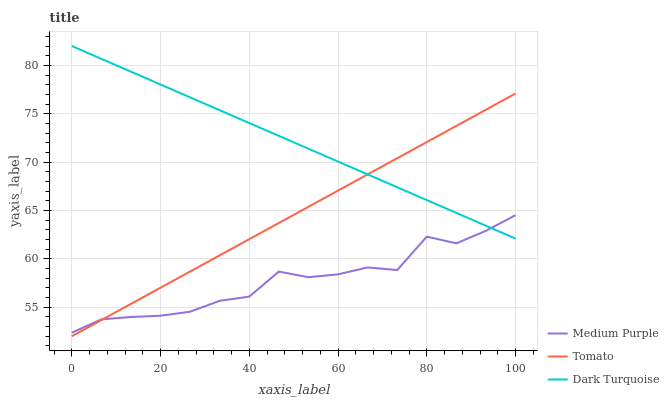Does Medium Purple have the minimum area under the curve?
Answer yes or no. Yes. Does Dark Turquoise have the maximum area under the curve?
Answer yes or no. Yes. Does Tomato have the minimum area under the curve?
Answer yes or no. No. Does Tomato have the maximum area under the curve?
Answer yes or no. No. Is Dark Turquoise the smoothest?
Answer yes or no. Yes. Is Medium Purple the roughest?
Answer yes or no. Yes. Is Tomato the smoothest?
Answer yes or no. No. Is Tomato the roughest?
Answer yes or no. No. Does Tomato have the lowest value?
Answer yes or no. Yes. Does Dark Turquoise have the lowest value?
Answer yes or no. No. Does Dark Turquoise have the highest value?
Answer yes or no. Yes. Does Tomato have the highest value?
Answer yes or no. No. Does Dark Turquoise intersect Tomato?
Answer yes or no. Yes. Is Dark Turquoise less than Tomato?
Answer yes or no. No. Is Dark Turquoise greater than Tomato?
Answer yes or no. No. 